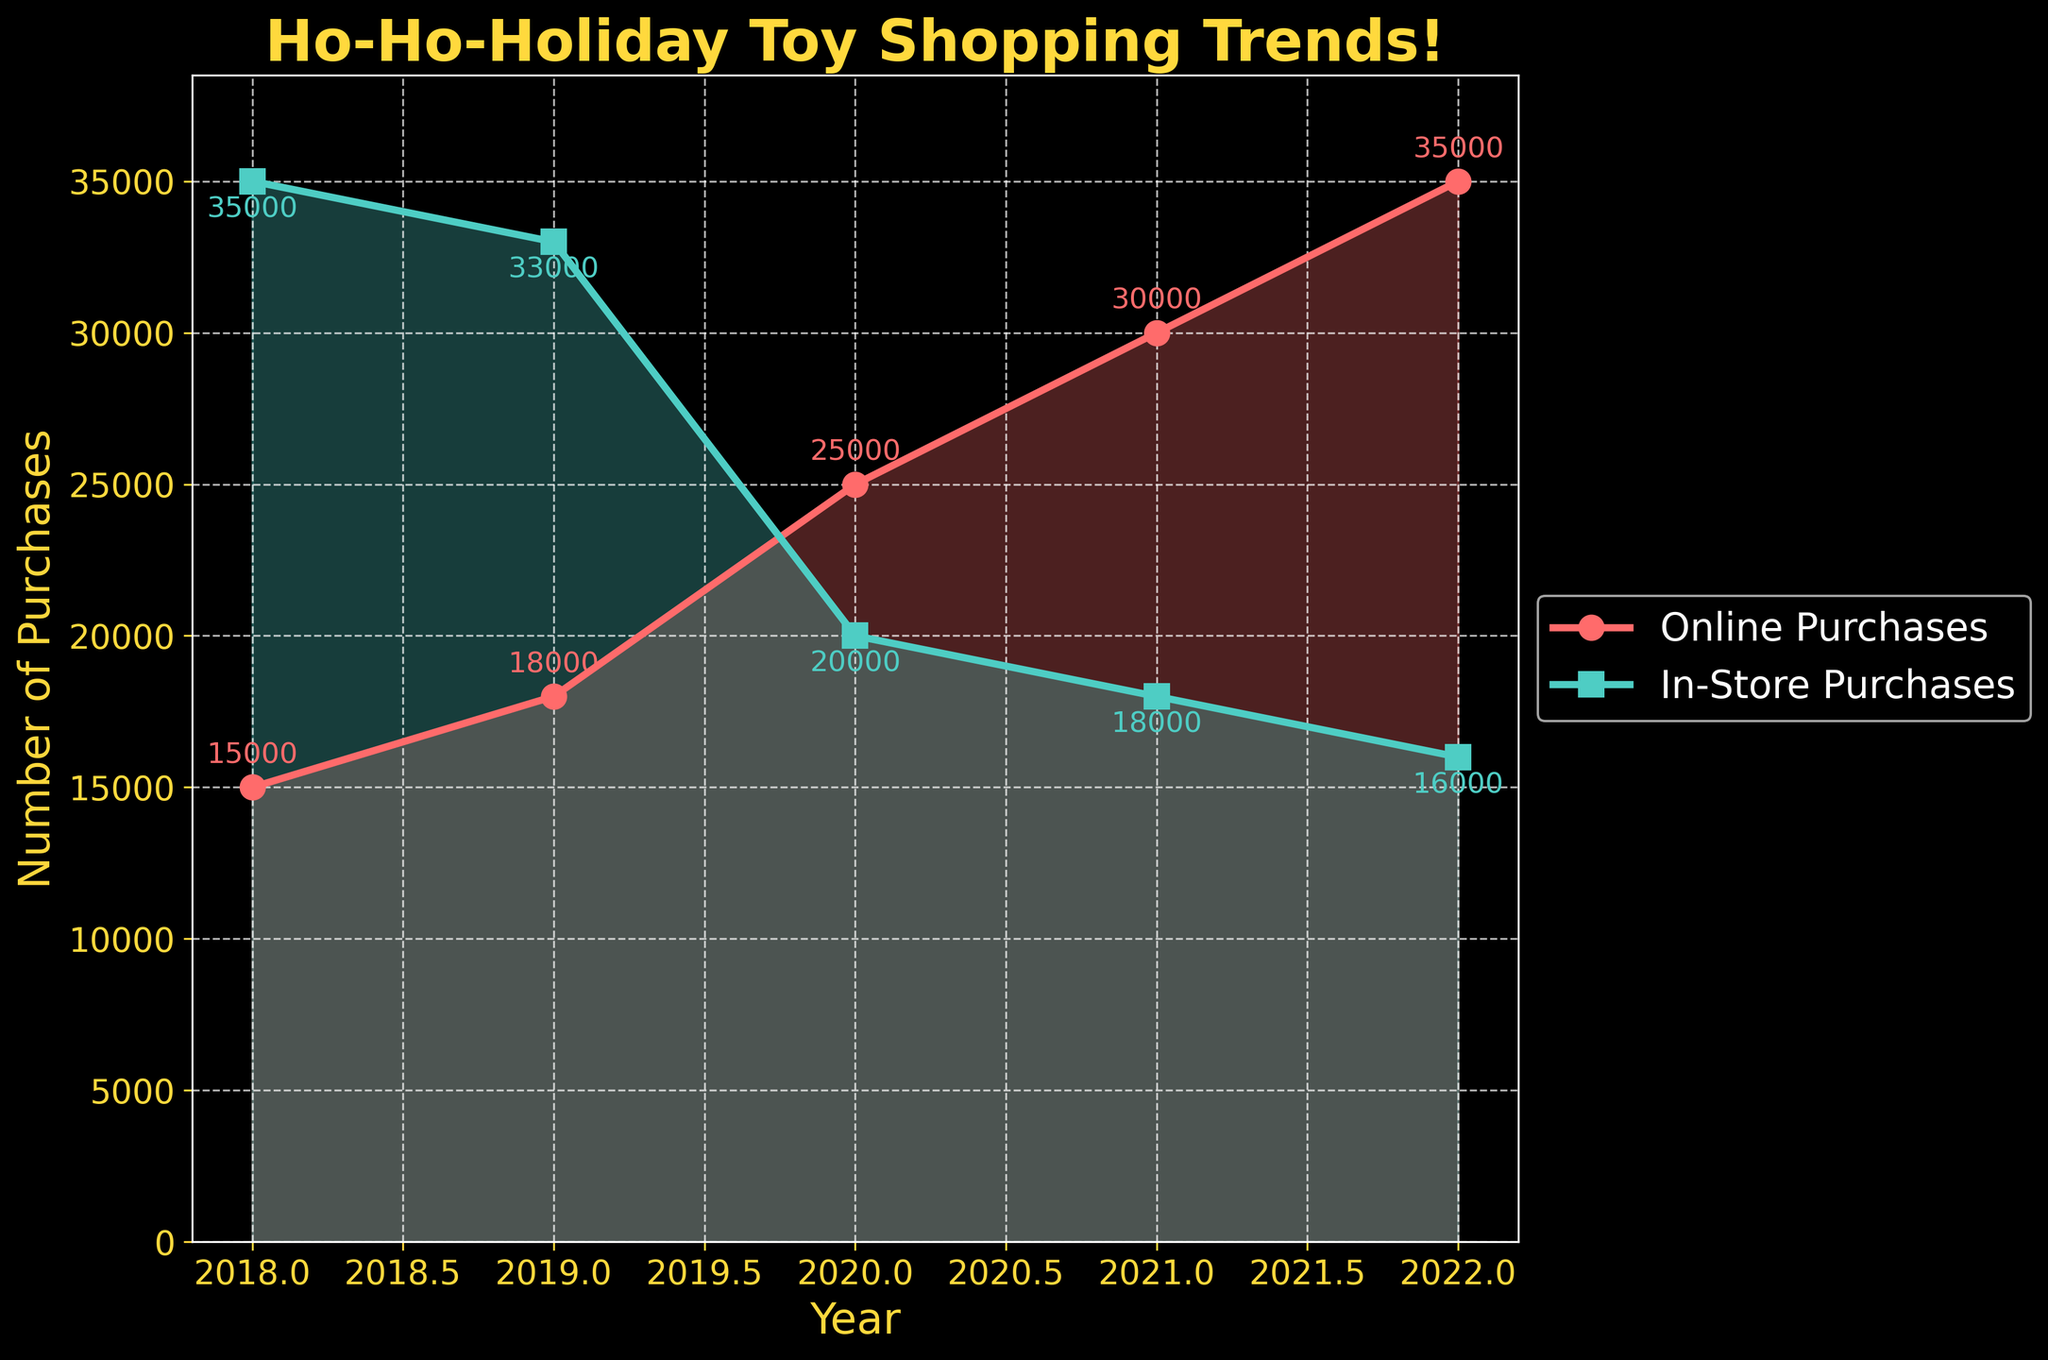What is the title of the plot? The title is located at the top of the plot in large and bold text to draw attention. It reads, "Ho-Ho-Holiday Toy Shopping Trends!"
Answer: Ho-Ho-Holiday Toy Shopping Trends! How many years of data are displayed in the plot? Look along the x-axis where the years are listed to count the number of distinct years shown. The plot features data from 2018 to 2022 inclusive
Answer: 5 Which year's online purchases are the highest? Observe the red line representing online purchases and identify the highest data point along the y-axis, which occurs in the year 2022.
Answer: 2022 What is the difference between online and in-store purchases in 2021? Find the data points for online and in-store purchases for the year 2021, and subtract the number of in-store purchases from the number of online purchases (30000 - 18000 = 12000)
Answer: 12000 In which year did in-store purchases decrease significantly, and how much was the difference from the previous year? Compare in-store purchases across consecutive years to pinpoint where the largest decrease occurs. The largest drop happened from 2019 to 2020 (33000 - 20000 = 13000).
Answer: 2020, 13000 Which purchase method saw an increase every year from 2018 to 2022? Look at the trend lines for both purchase methods. The red line (online purchases) shows a steady increase every year, while the green line (in-store purchases) shows a decrease.
Answer: Online purchases What is the color of the line representing in-store purchases? The line representing in-store purchases can be identified by its distinctive green color used throughout the plot.
Answer: Green How many purchases were made online in 2019? Refer to the plot and find the data point for online purchases in 2019, where the red line is marked with a number.
Answer: 18000 Which year had the smallest gap between online and in-store purchases, and what is that gap? Examine the plot to calculate the differences between online and in-store purchases for each year. The smallest gap appears in 2022 (35000 - 16000 = 19000).
Answer: 2022, 19000 What trend can be observed in in-store purchases over the years? Follow the green line representing in-store purchases from 2018 to 2022 and note the downward slope, which indicates a continuous decline over the years.
Answer: Continuous decline 